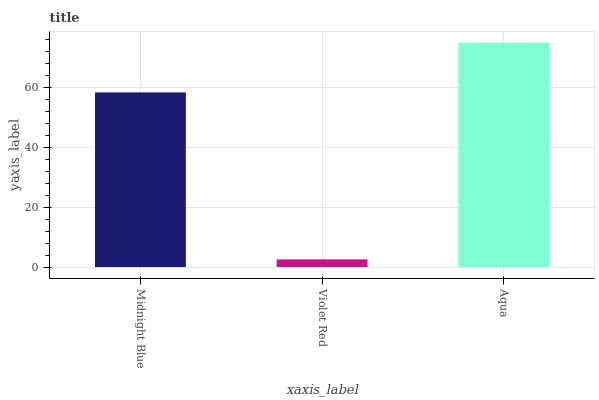Is Violet Red the minimum?
Answer yes or no. Yes. Is Aqua the maximum?
Answer yes or no. Yes. Is Aqua the minimum?
Answer yes or no. No. Is Violet Red the maximum?
Answer yes or no. No. Is Aqua greater than Violet Red?
Answer yes or no. Yes. Is Violet Red less than Aqua?
Answer yes or no. Yes. Is Violet Red greater than Aqua?
Answer yes or no. No. Is Aqua less than Violet Red?
Answer yes or no. No. Is Midnight Blue the high median?
Answer yes or no. Yes. Is Midnight Blue the low median?
Answer yes or no. Yes. Is Aqua the high median?
Answer yes or no. No. Is Aqua the low median?
Answer yes or no. No. 